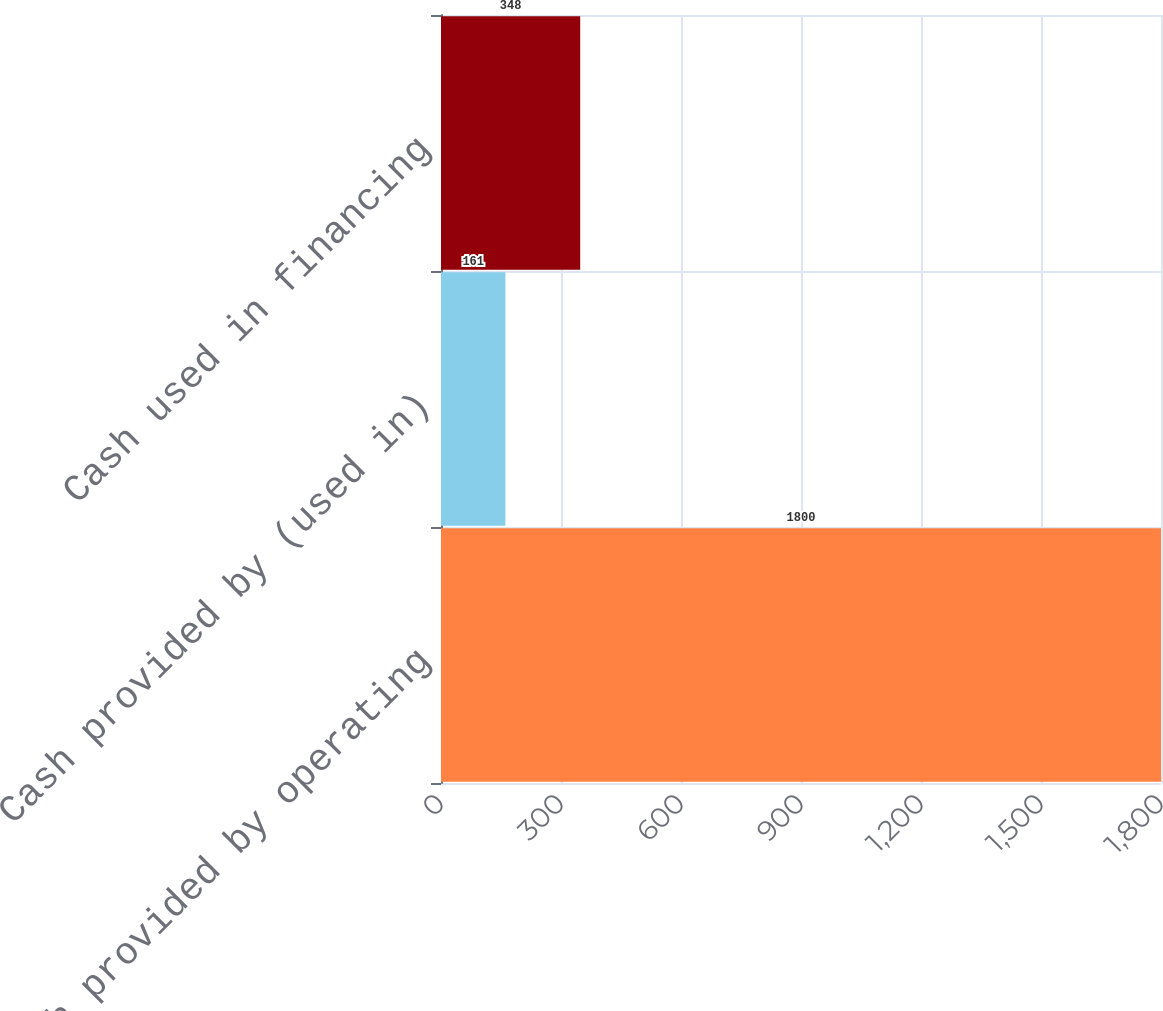<chart> <loc_0><loc_0><loc_500><loc_500><bar_chart><fcel>Cash provided by operating<fcel>Cash provided by (used in)<fcel>Cash used in financing<nl><fcel>1800<fcel>161<fcel>348<nl></chart> 